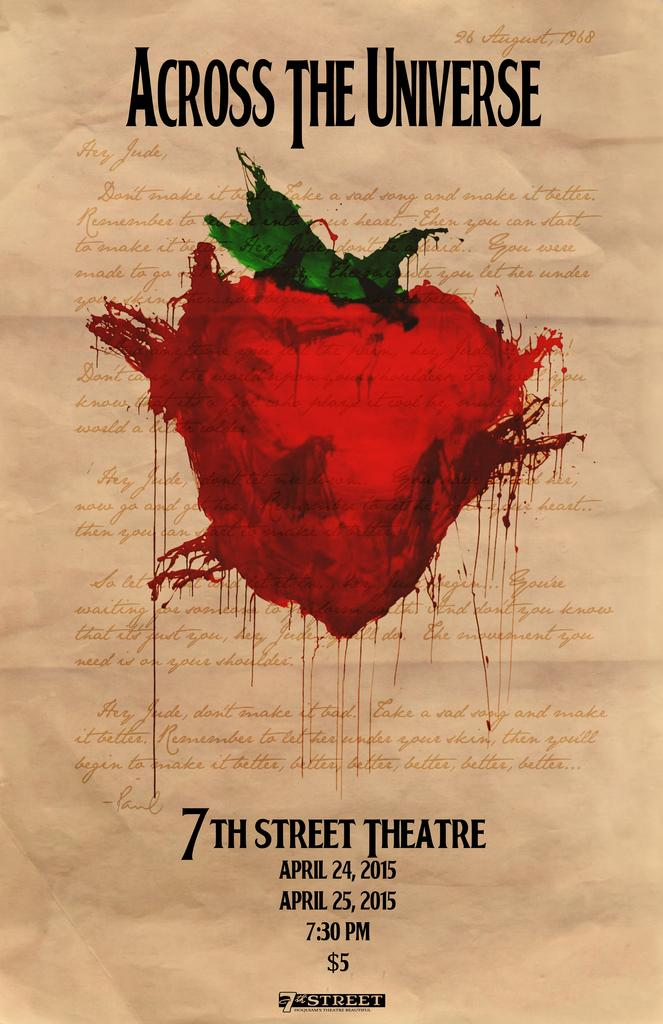<image>
Create a compact narrative representing the image presented. Across The Universe was showing at the 7th Street Theatre for $5. 